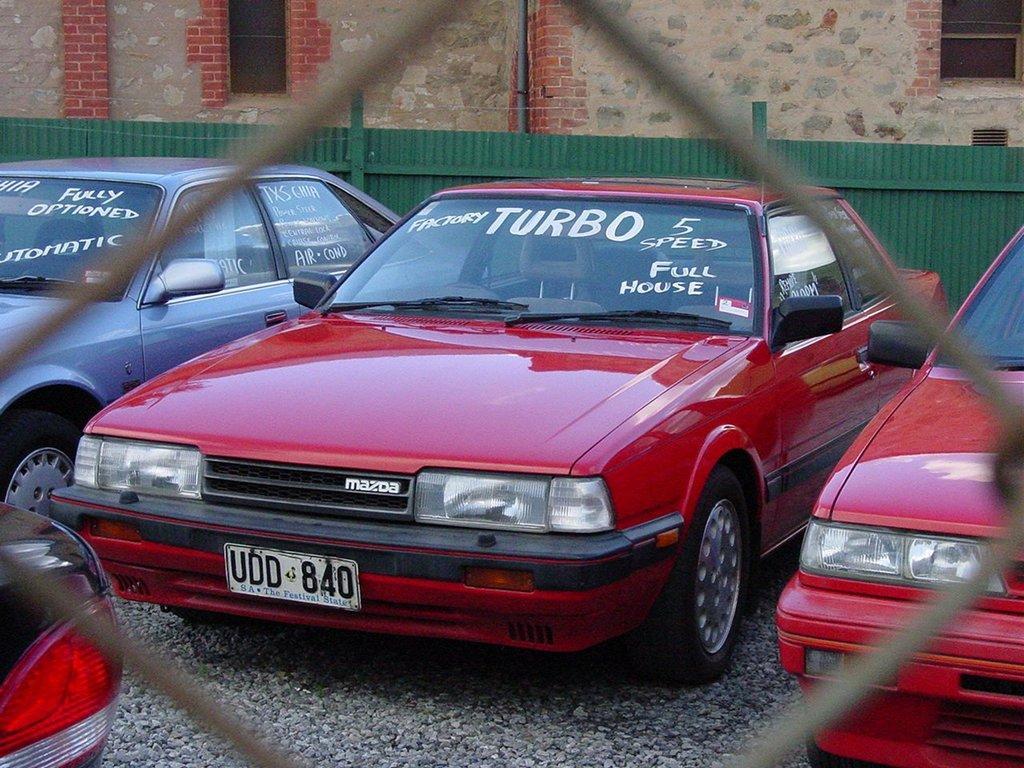Could you give a brief overview of what you see in this image? There are 3-4 car, one car at left side one car at middle ,one car at the right side and last one at the bottom left corner. 